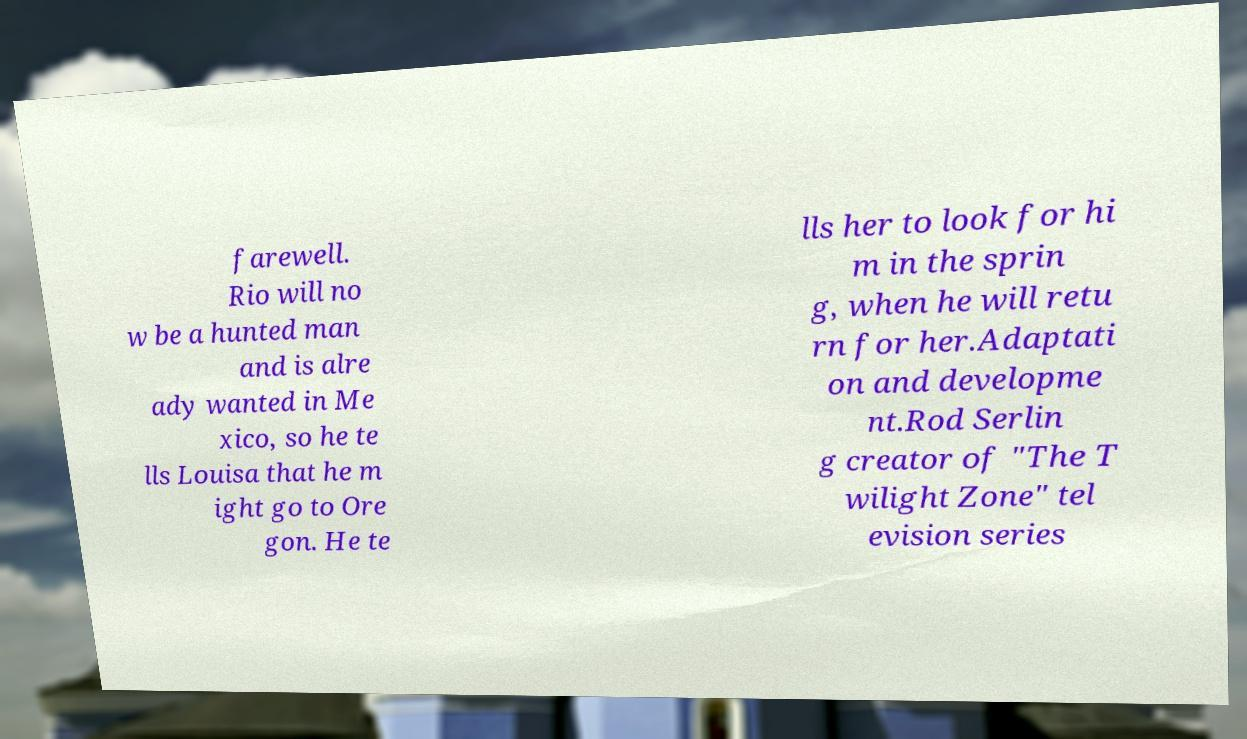Please read and relay the text visible in this image. What does it say? farewell. Rio will no w be a hunted man and is alre ady wanted in Me xico, so he te lls Louisa that he m ight go to Ore gon. He te lls her to look for hi m in the sprin g, when he will retu rn for her.Adaptati on and developme nt.Rod Serlin g creator of "The T wilight Zone" tel evision series 